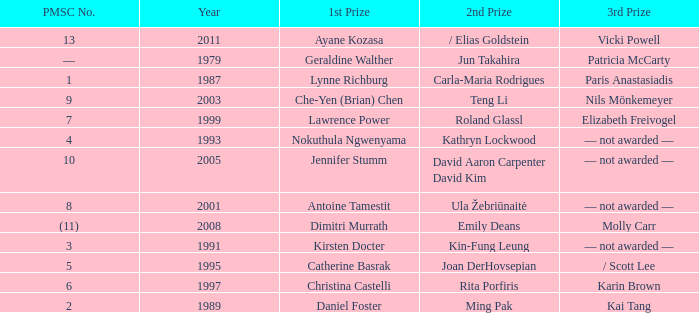In what year did Kin-fung Leung get 2nd prize? 1991.0. 